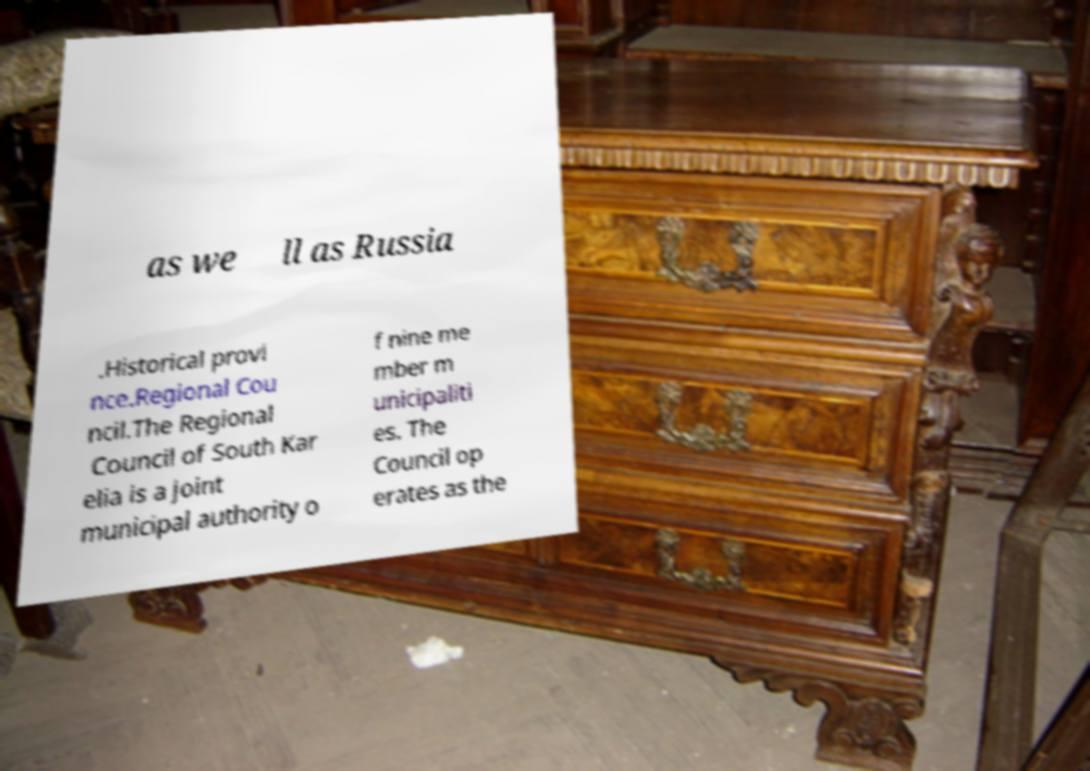Can you accurately transcribe the text from the provided image for me? as we ll as Russia .Historical provi nce.Regional Cou ncil.The Regional Council of South Kar elia is a joint municipal authority o f nine me mber m unicipaliti es. The Council op erates as the 